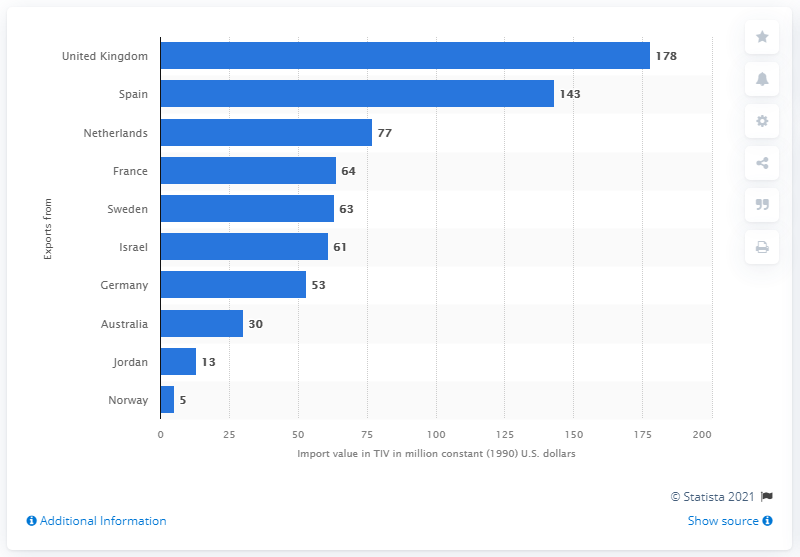Specify some key components in this picture. In 1990, the amount of constant U.S. dollars allocated to arms imports from Australia was 30. 